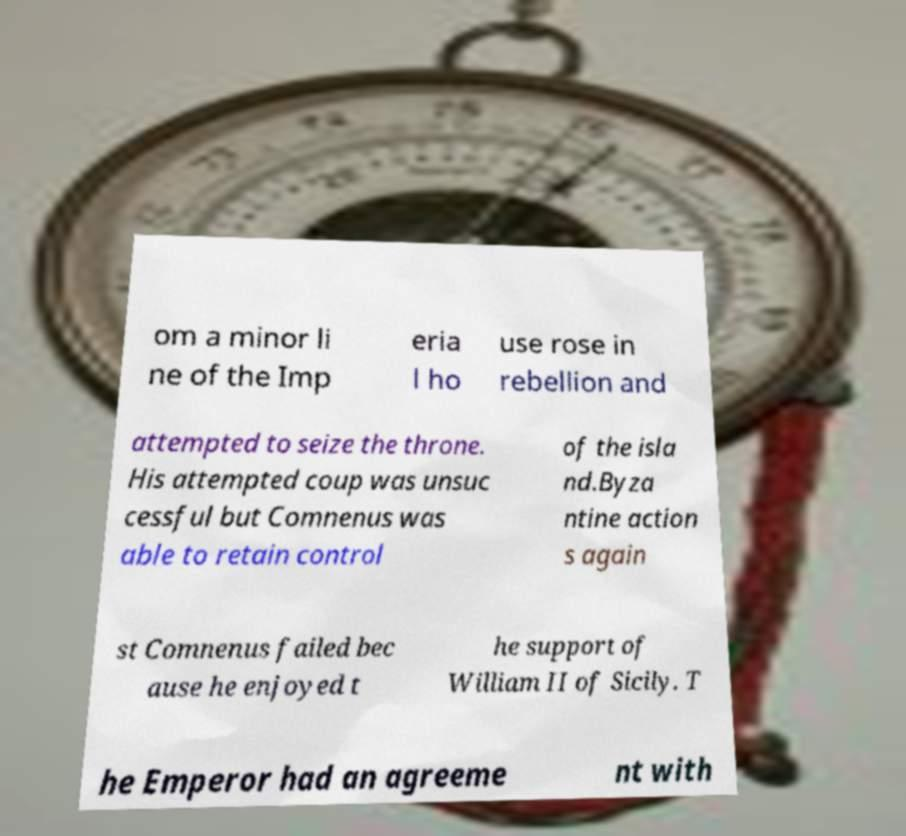Please identify and transcribe the text found in this image. om a minor li ne of the Imp eria l ho use rose in rebellion and attempted to seize the throne. His attempted coup was unsuc cessful but Comnenus was able to retain control of the isla nd.Byza ntine action s again st Comnenus failed bec ause he enjoyed t he support of William II of Sicily. T he Emperor had an agreeme nt with 